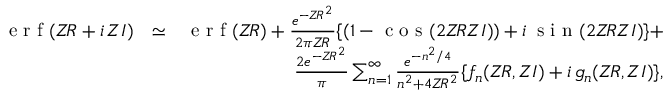<formula> <loc_0><loc_0><loc_500><loc_500>\begin{array} { r l r } { e r f ( Z \, R + i \, Z I ) } & { \simeq } & { e r f ( Z \, R ) + \frac { e ^ { - Z \, R ^ { 2 } } } { 2 \pi Z \, R } \{ ( 1 - \cos ( 2 Z \, R Z I ) ) + i \, \sin ( 2 Z \, R Z I ) \} + } \\ & { \frac { 2 e ^ { - Z \, R ^ { 2 } } } { \pi } \sum _ { n = 1 } ^ { \infty } \frac { e ^ { - n ^ { 2 } / 4 } } { n ^ { 2 } + 4 Z \, R ^ { 2 } } \{ f _ { n } ( Z \, R , Z I ) + i \, g _ { n } ( Z \, R , Z I ) \} , } \end{array}</formula> 